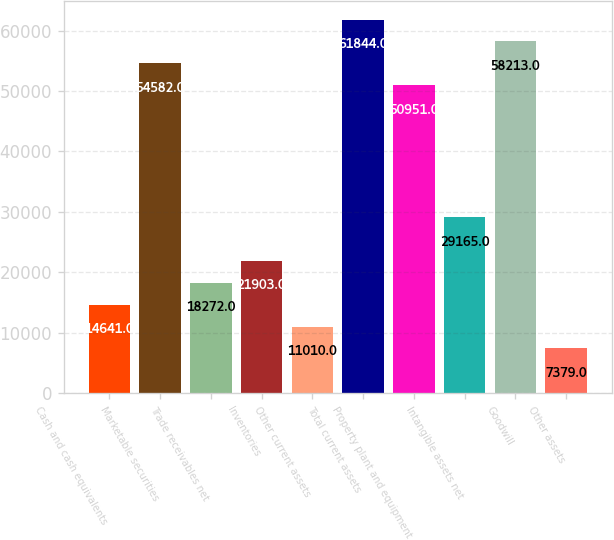<chart> <loc_0><loc_0><loc_500><loc_500><bar_chart><fcel>Cash and cash equivalents<fcel>Marketable securities<fcel>Trade receivables net<fcel>Inventories<fcel>Other current assets<fcel>Total current assets<fcel>Property plant and equipment<fcel>Intangible assets net<fcel>Goodwill<fcel>Other assets<nl><fcel>14641<fcel>54582<fcel>18272<fcel>21903<fcel>11010<fcel>61844<fcel>50951<fcel>29165<fcel>58213<fcel>7379<nl></chart> 